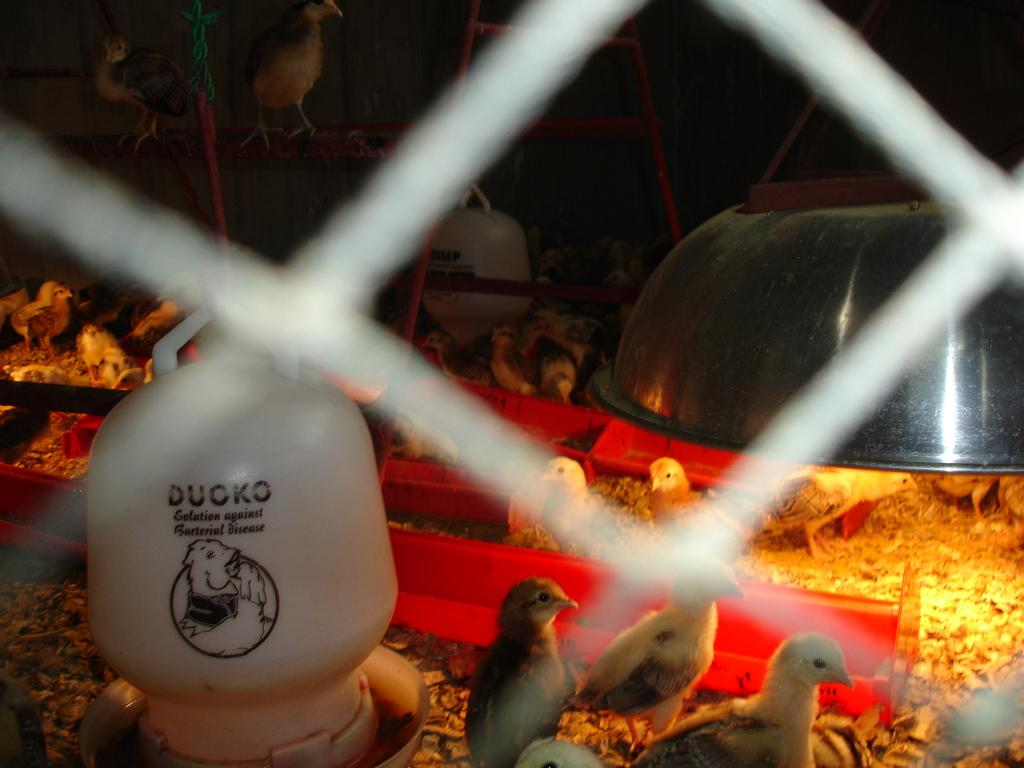What is located in the center of the image? There is a jar, a bowl, a light, poles, and birds in the center of the image. Can you describe the jar in the image? The jar is in the center of the image. What is the purpose of the light in the image? The light is in the center of the image, but its purpose is not specified. What type of birds can be seen in the image? There are birds in the center of the image, but their species is not specified. Are there any other objects in the center of the image besides the ones mentioned? Yes, there are other objects in the center of the image, but their nature is not specified. Who is the owner of the cloth in the image? There is no cloth present in the image, so it is not possible to determine the owner. 